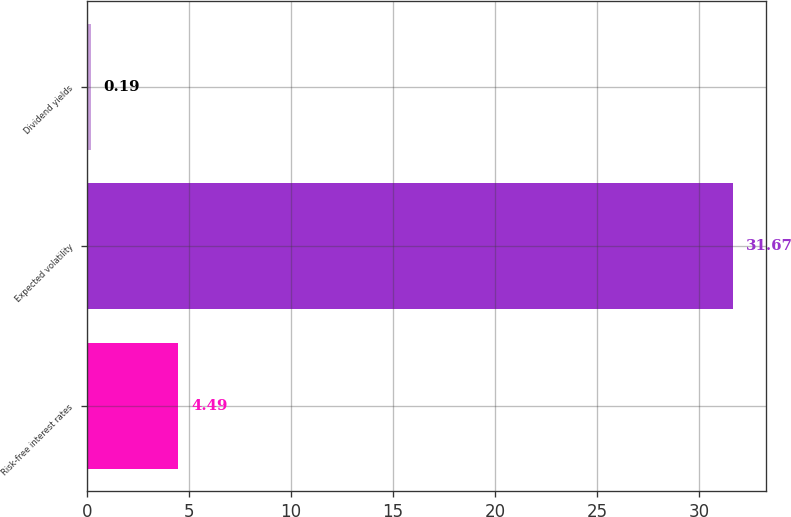Convert chart. <chart><loc_0><loc_0><loc_500><loc_500><bar_chart><fcel>Risk-free interest rates<fcel>Expected volatility<fcel>Dividend yields<nl><fcel>4.49<fcel>31.67<fcel>0.19<nl></chart> 